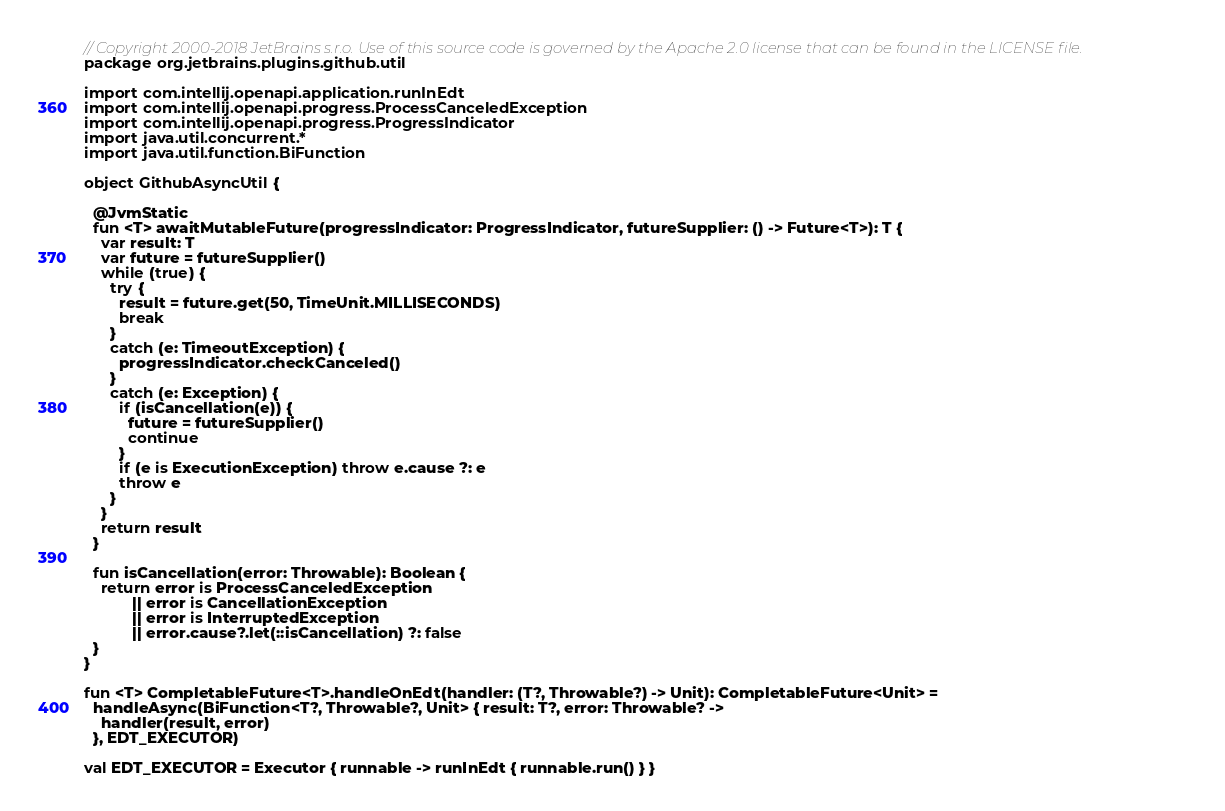<code> <loc_0><loc_0><loc_500><loc_500><_Kotlin_>// Copyright 2000-2018 JetBrains s.r.o. Use of this source code is governed by the Apache 2.0 license that can be found in the LICENSE file.
package org.jetbrains.plugins.github.util

import com.intellij.openapi.application.runInEdt
import com.intellij.openapi.progress.ProcessCanceledException
import com.intellij.openapi.progress.ProgressIndicator
import java.util.concurrent.*
import java.util.function.BiFunction

object GithubAsyncUtil {

  @JvmStatic
  fun <T> awaitMutableFuture(progressIndicator: ProgressIndicator, futureSupplier: () -> Future<T>): T {
    var result: T
    var future = futureSupplier()
    while (true) {
      try {
        result = future.get(50, TimeUnit.MILLISECONDS)
        break
      }
      catch (e: TimeoutException) {
        progressIndicator.checkCanceled()
      }
      catch (e: Exception) {
        if (isCancellation(e)) {
          future = futureSupplier()
          continue
        }
        if (e is ExecutionException) throw e.cause ?: e
        throw e
      }
    }
    return result
  }

  fun isCancellation(error: Throwable): Boolean {
    return error is ProcessCanceledException
           || error is CancellationException
           || error is InterruptedException
           || error.cause?.let(::isCancellation) ?: false
  }
}

fun <T> CompletableFuture<T>.handleOnEdt(handler: (T?, Throwable?) -> Unit): CompletableFuture<Unit> =
  handleAsync(BiFunction<T?, Throwable?, Unit> { result: T?, error: Throwable? ->
    handler(result, error)
  }, EDT_EXECUTOR)

val EDT_EXECUTOR = Executor { runnable -> runInEdt { runnable.run() } }</code> 